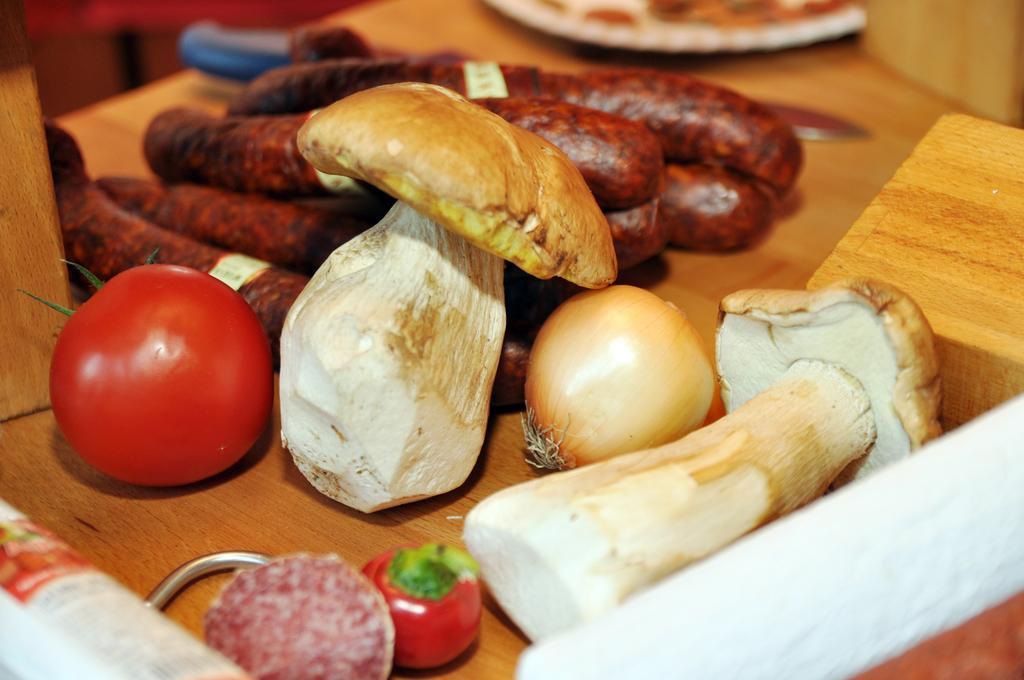Can you describe this image briefly? In this image I can see mushrooms, tomatoes, onion and other food items on a wooden surface. 